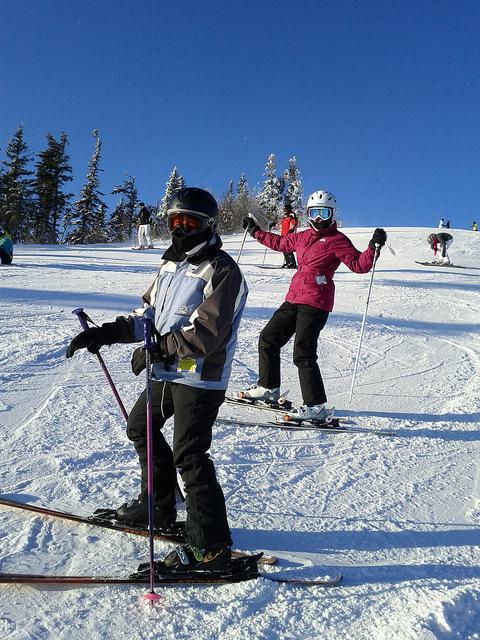How many people are visible?
Give a very brief answer. 2. 